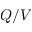Convert formula to latex. <formula><loc_0><loc_0><loc_500><loc_500>Q / V</formula> 